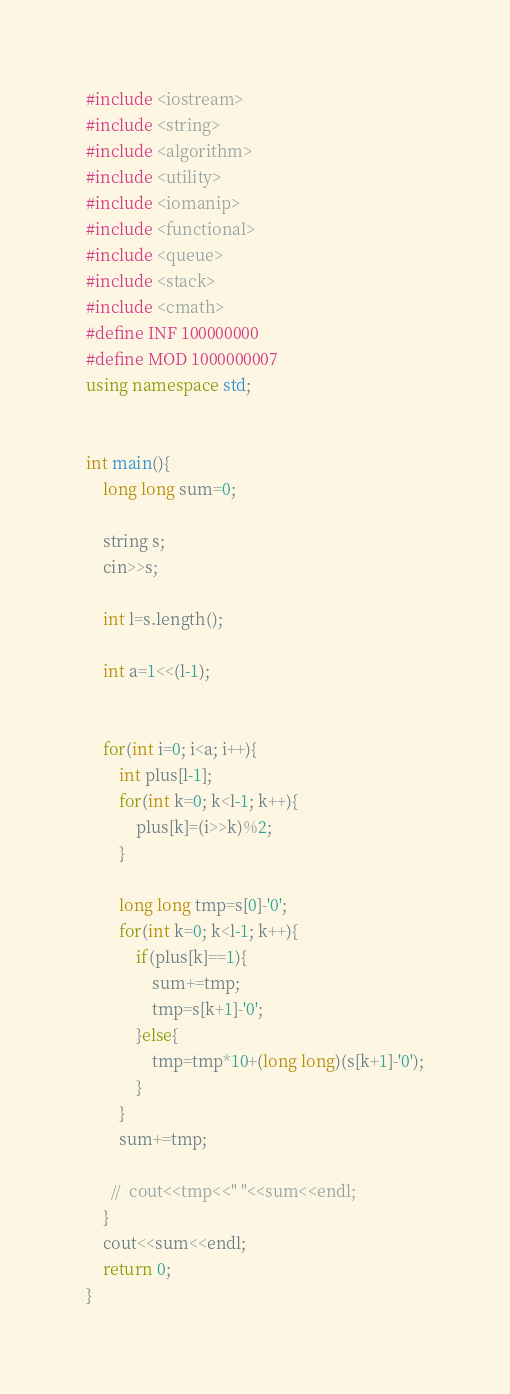<code> <loc_0><loc_0><loc_500><loc_500><_C++_>#include <iostream>
#include <string>
#include <algorithm>
#include <utility>
#include <iomanip>
#include <functional>
#include <queue>
#include <stack>
#include <cmath>
#define INF 100000000
#define MOD 1000000007
using namespace std;


int main(){
    long long sum=0;
    
    string s;
    cin>>s;
    
    int l=s.length();
    
    int a=1<<(l-1);
    
    
    for(int i=0; i<a; i++){
        int plus[l-1];
        for(int k=0; k<l-1; k++){
            plus[k]=(i>>k)%2;
        }
        
        long long tmp=s[0]-'0';
        for(int k=0; k<l-1; k++){
            if(plus[k]==1){
                sum+=tmp;
                tmp=s[k+1]-'0';
            }else{
                tmp=tmp*10+(long long)(s[k+1]-'0');
            }
        }
        sum+=tmp;
        
      //  cout<<tmp<<" "<<sum<<endl;
    }
    cout<<sum<<endl;
    return 0;
}
</code> 